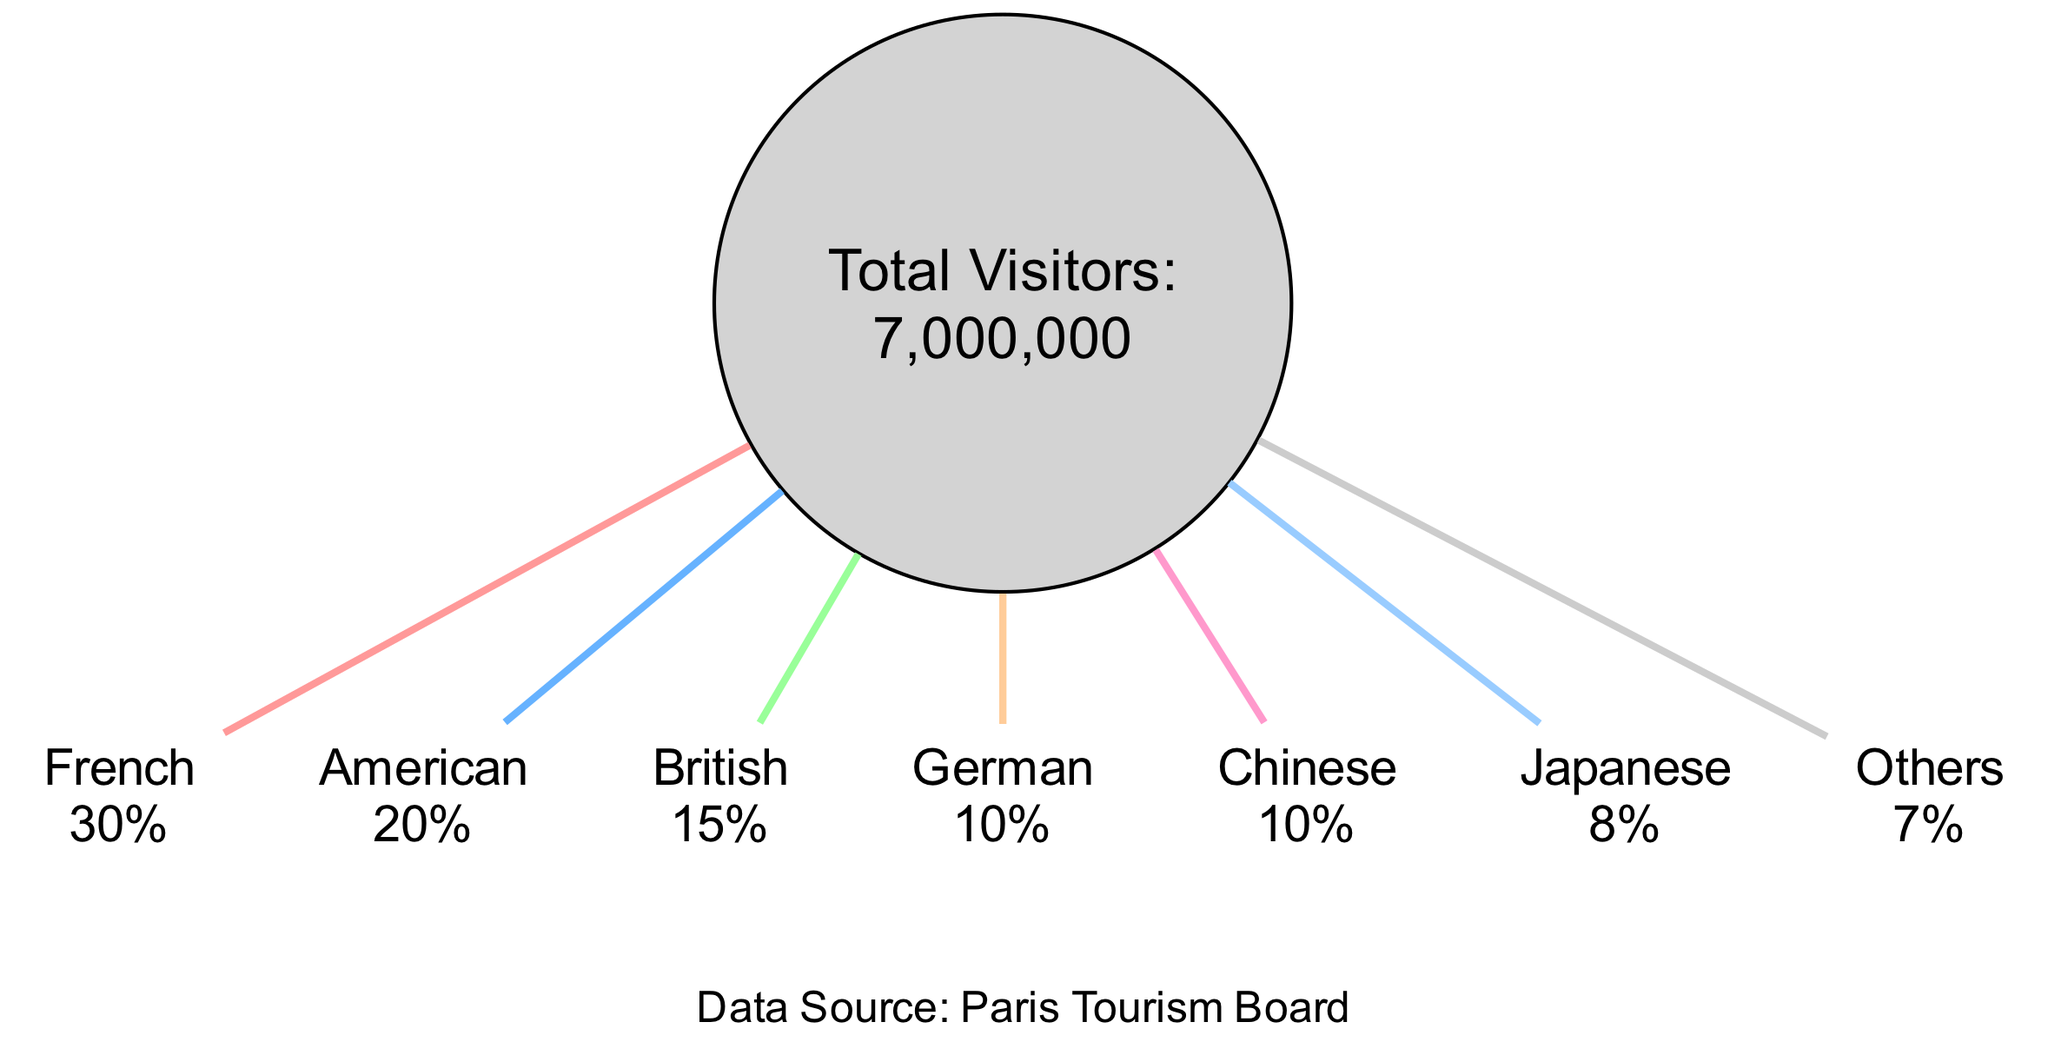What is the nationality that represents the largest slice of visitors? The diagram shows that the largest slice of visitors is French, which is indicated at the highest percentage of 30%.
Answer: French How many total visitors were recorded at the Eiffel Tower in 2023? The total number of visitors is clearly stated in the diagram as 7,000,000.
Answer: 7000000 What percentage of visitors are American? The diagram marks the American slice at 20%, which is easily identifiable within the pie chart.
Answer: 20% What is the total percentage represented by the 'Others' category? The 'Others' category is specified in the diagram with a percentage of 7%, making it straightforward to answer.
Answer: 7% How many nationalities are represented in the diagram? There are a total of 7 entries listed in the slices, representing different nationalities visiting the attraction.
Answer: 7 Which two nationalities together account for more than half of the visitors? Adding the percentages of French (30%) and American (20%), we achieve a total of 50%, indicating that these two nationalities account for exactly half of the visitors.
Answer: French and American What percentage of tourists coming from British nationality? The British slice explicitly shows a percentage of 15% in the diagram, making it simple to extract this information.
Answer: 15% How does the percentage of Japanese visitors compare to that of German visitors? The diagram indicates that Japanese visitors account for 8%, while German visitors account for 10%. Since 10% is greater than 8%, German visitors have a higher percentage.
Answer: German more than Japanese What is the total percentage of visitors that are either German or Chinese? The German percentage is 10% and the Chinese percentage is also 10%, so summing these two gives a total of 20%.
Answer: 20% 